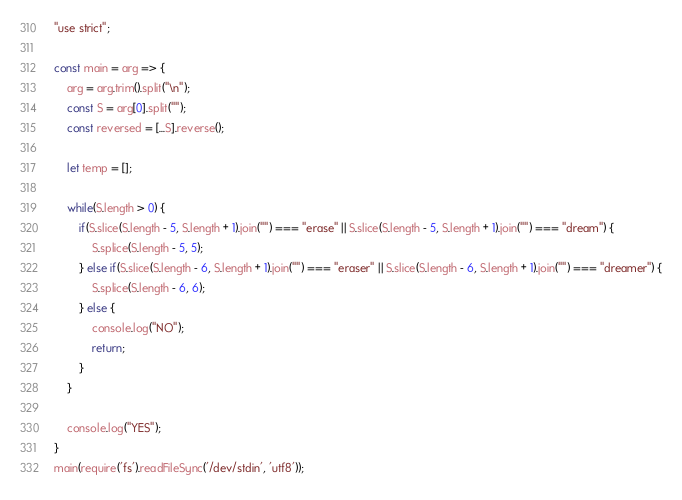Convert code to text. <code><loc_0><loc_0><loc_500><loc_500><_JavaScript_>"use strict";
    
const main = arg => {
    arg = arg.trim().split("\n");
    const S = arg[0].split("");
    const reversed = [...S].reverse();
    
    let temp = [];
    
    while(S.length > 0) {
        if(S.slice(S.length - 5, S.length + 1).join("") === "erase" || S.slice(S.length - 5, S.length + 1).join("") === "dream") {
            S.splice(S.length - 5, 5);
        } else if(S.slice(S.length - 6, S.length + 1).join("") === "eraser" || S.slice(S.length - 6, S.length + 1).join("") === "dreamer") {
            S.splice(S.length - 6, 6);
        } else {
            console.log("NO");
            return;
        }
    }
    
    console.log("YES");
}
main(require('fs').readFileSync('/dev/stdin', 'utf8'));</code> 